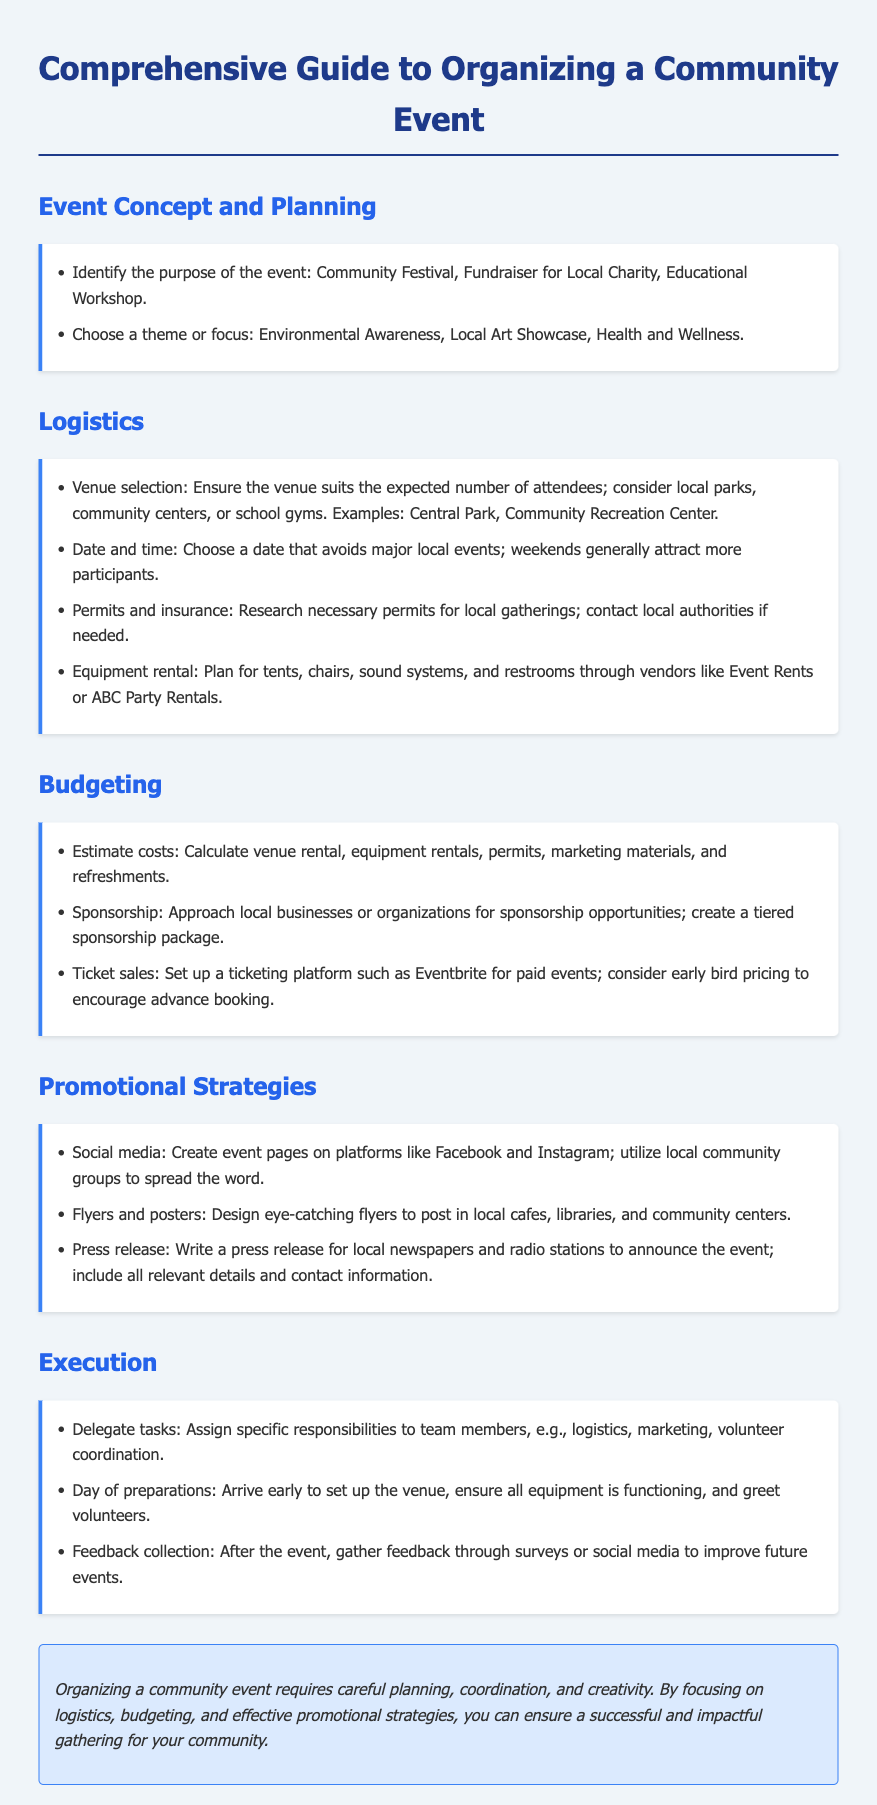What are the types of events mentioned? The document lists types of events to consider, which include Community Festival, Fundraiser for Local Charity, and Educational Workshop.
Answer: Community Festival, Fundraiser for Local Charity, Educational Workshop Which section addresses budgeting? The document includes a section specifically titled "Budgeting" that discusses various financial aspects related to event organization.
Answer: Budgeting What is one strategy for promoting the event? The promotional strategies section mentions creating event pages on social media platforms as a method of promotion.
Answer: Social media How should permits be handled according to the guide? The logistics section outlines the need to research necessary permits for local gatherings and recommends contacting local authorities.
Answer: Research necessary permits When should the event date be chosen? The document advises selecting a date that avoids major local events and mentions that weekends generally attract more participants.
Answer: Avoid major local events; weekends What is one way to estimate costs? To estimate costs, the guide suggests calculating venue rental, equipment rentals, permits, marketing materials, and refreshments.
Answer: Calculate venue rental, equipment rentals, permits, marketing materials, and refreshments What gives insight into the event’s theme? The document indicates choosing a theme or focus, providing examples like Environmental Awareness and Local Art Showcase for planning.
Answer: Environmental Awareness, Local Art Showcase What should be included in a press release? The document advises including all relevant details and contact information in the press release for local newspapers and radio stations.
Answer: All relevant details and contact information 